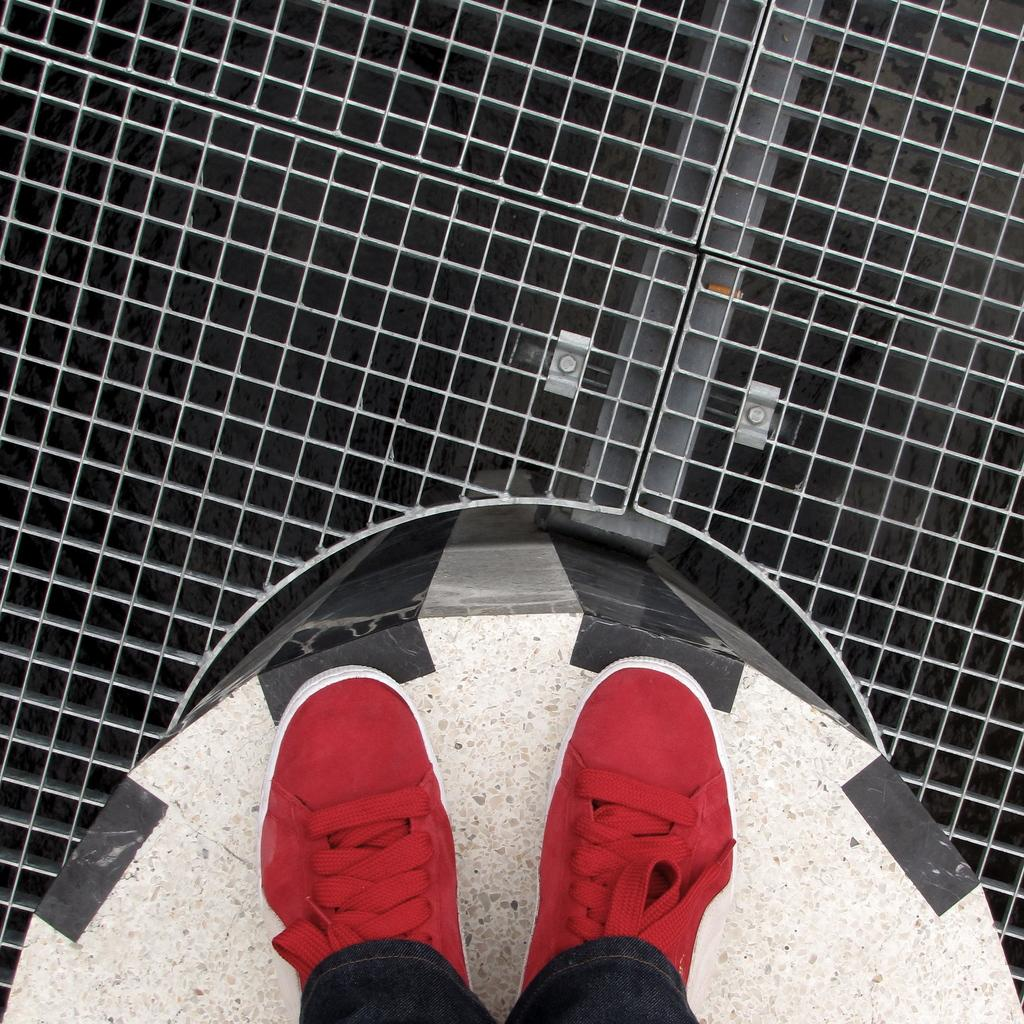What is the person in the image doing? The person is standing on a wall in the image. Where is the wall located in the image? The wall is at the bottom of the image. What can be seen at the top of the image? There is a gate at the top of the image. What type of milk is being used to create the effect on the wall in the image? There is no milk or any effect on the wall in the image; it simply shows a person standing on a wall with a gate at the top. 